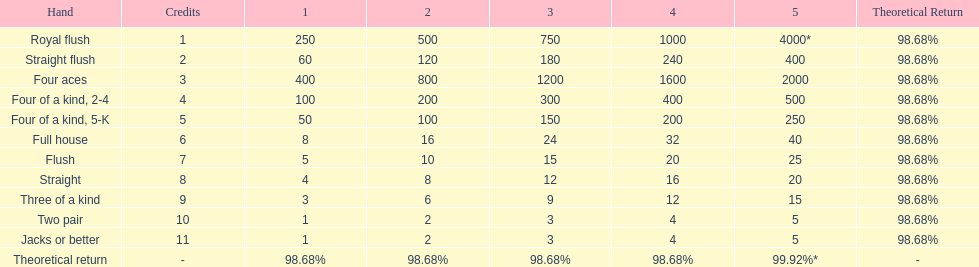How many straight wins at 3 credits equals one straight flush win at two credits? 10. 